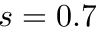Convert formula to latex. <formula><loc_0><loc_0><loc_500><loc_500>s = 0 . 7</formula> 